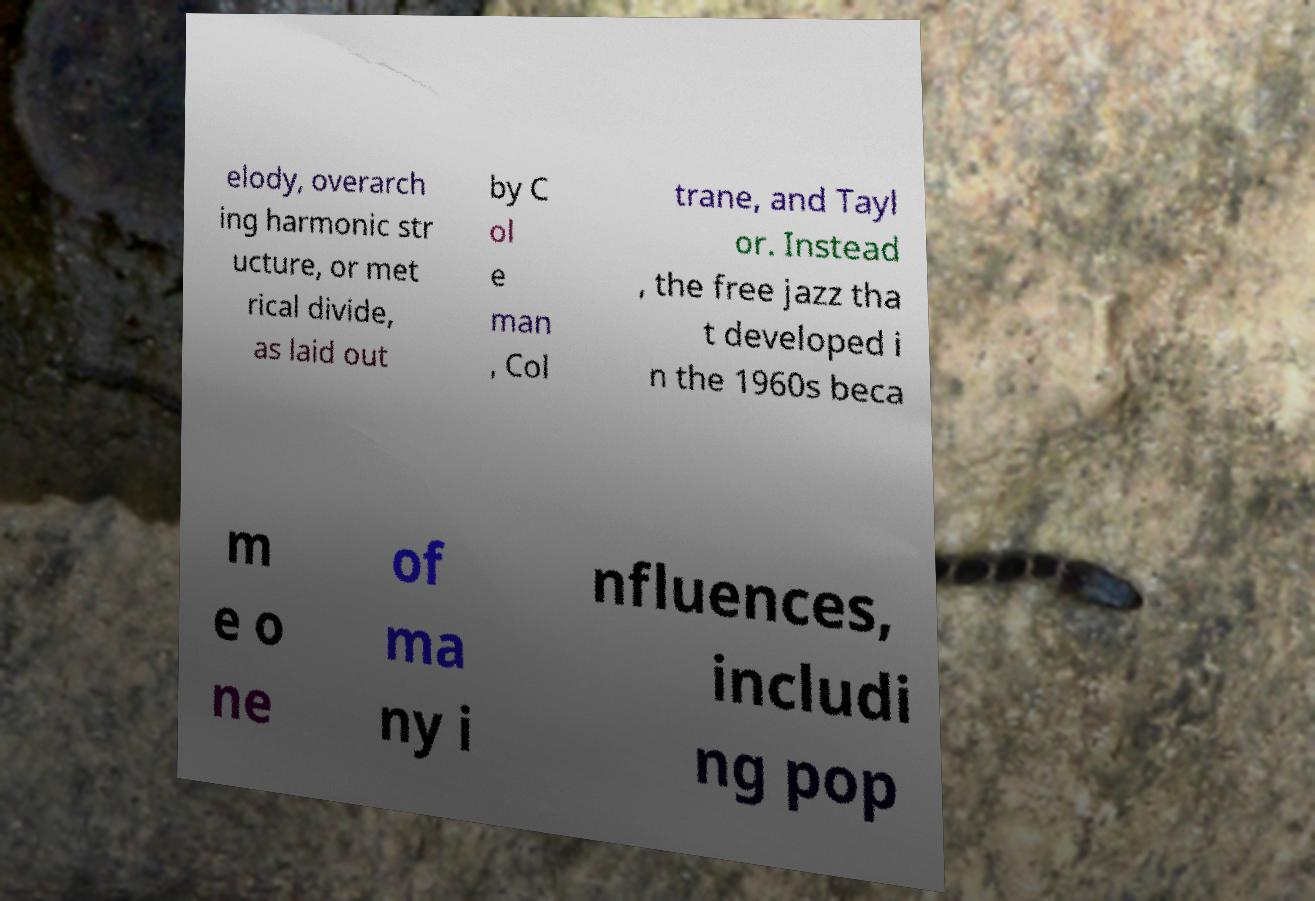Can you read and provide the text displayed in the image?This photo seems to have some interesting text. Can you extract and type it out for me? elody, overarch ing harmonic str ucture, or met rical divide, as laid out by C ol e man , Col trane, and Tayl or. Instead , the free jazz tha t developed i n the 1960s beca m e o ne of ma ny i nfluences, includi ng pop 